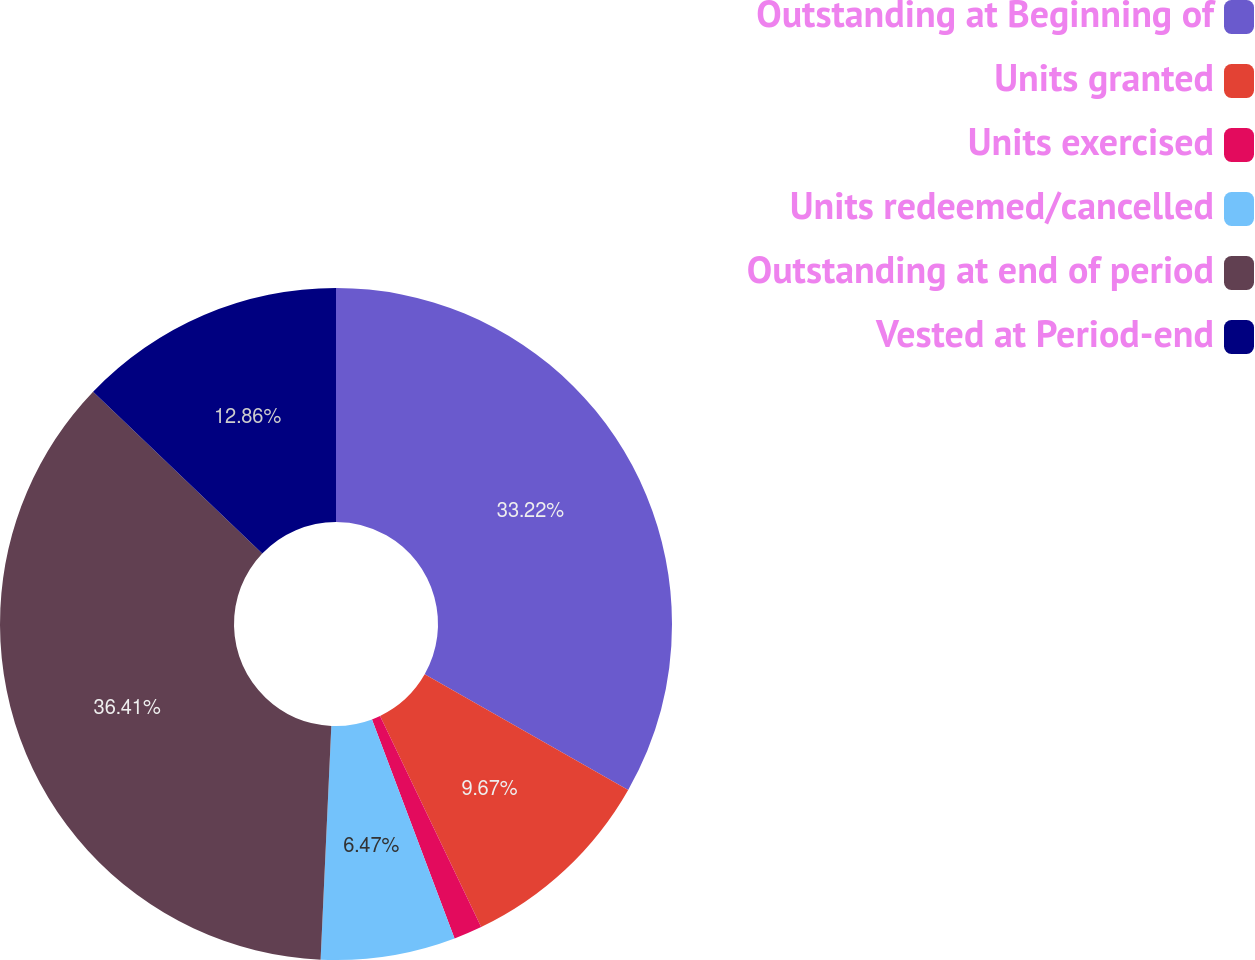<chart> <loc_0><loc_0><loc_500><loc_500><pie_chart><fcel>Outstanding at Beginning of<fcel>Units granted<fcel>Units exercised<fcel>Units redeemed/cancelled<fcel>Outstanding at end of period<fcel>Vested at Period-end<nl><fcel>33.22%<fcel>9.67%<fcel>1.37%<fcel>6.47%<fcel>36.41%<fcel>12.86%<nl></chart> 